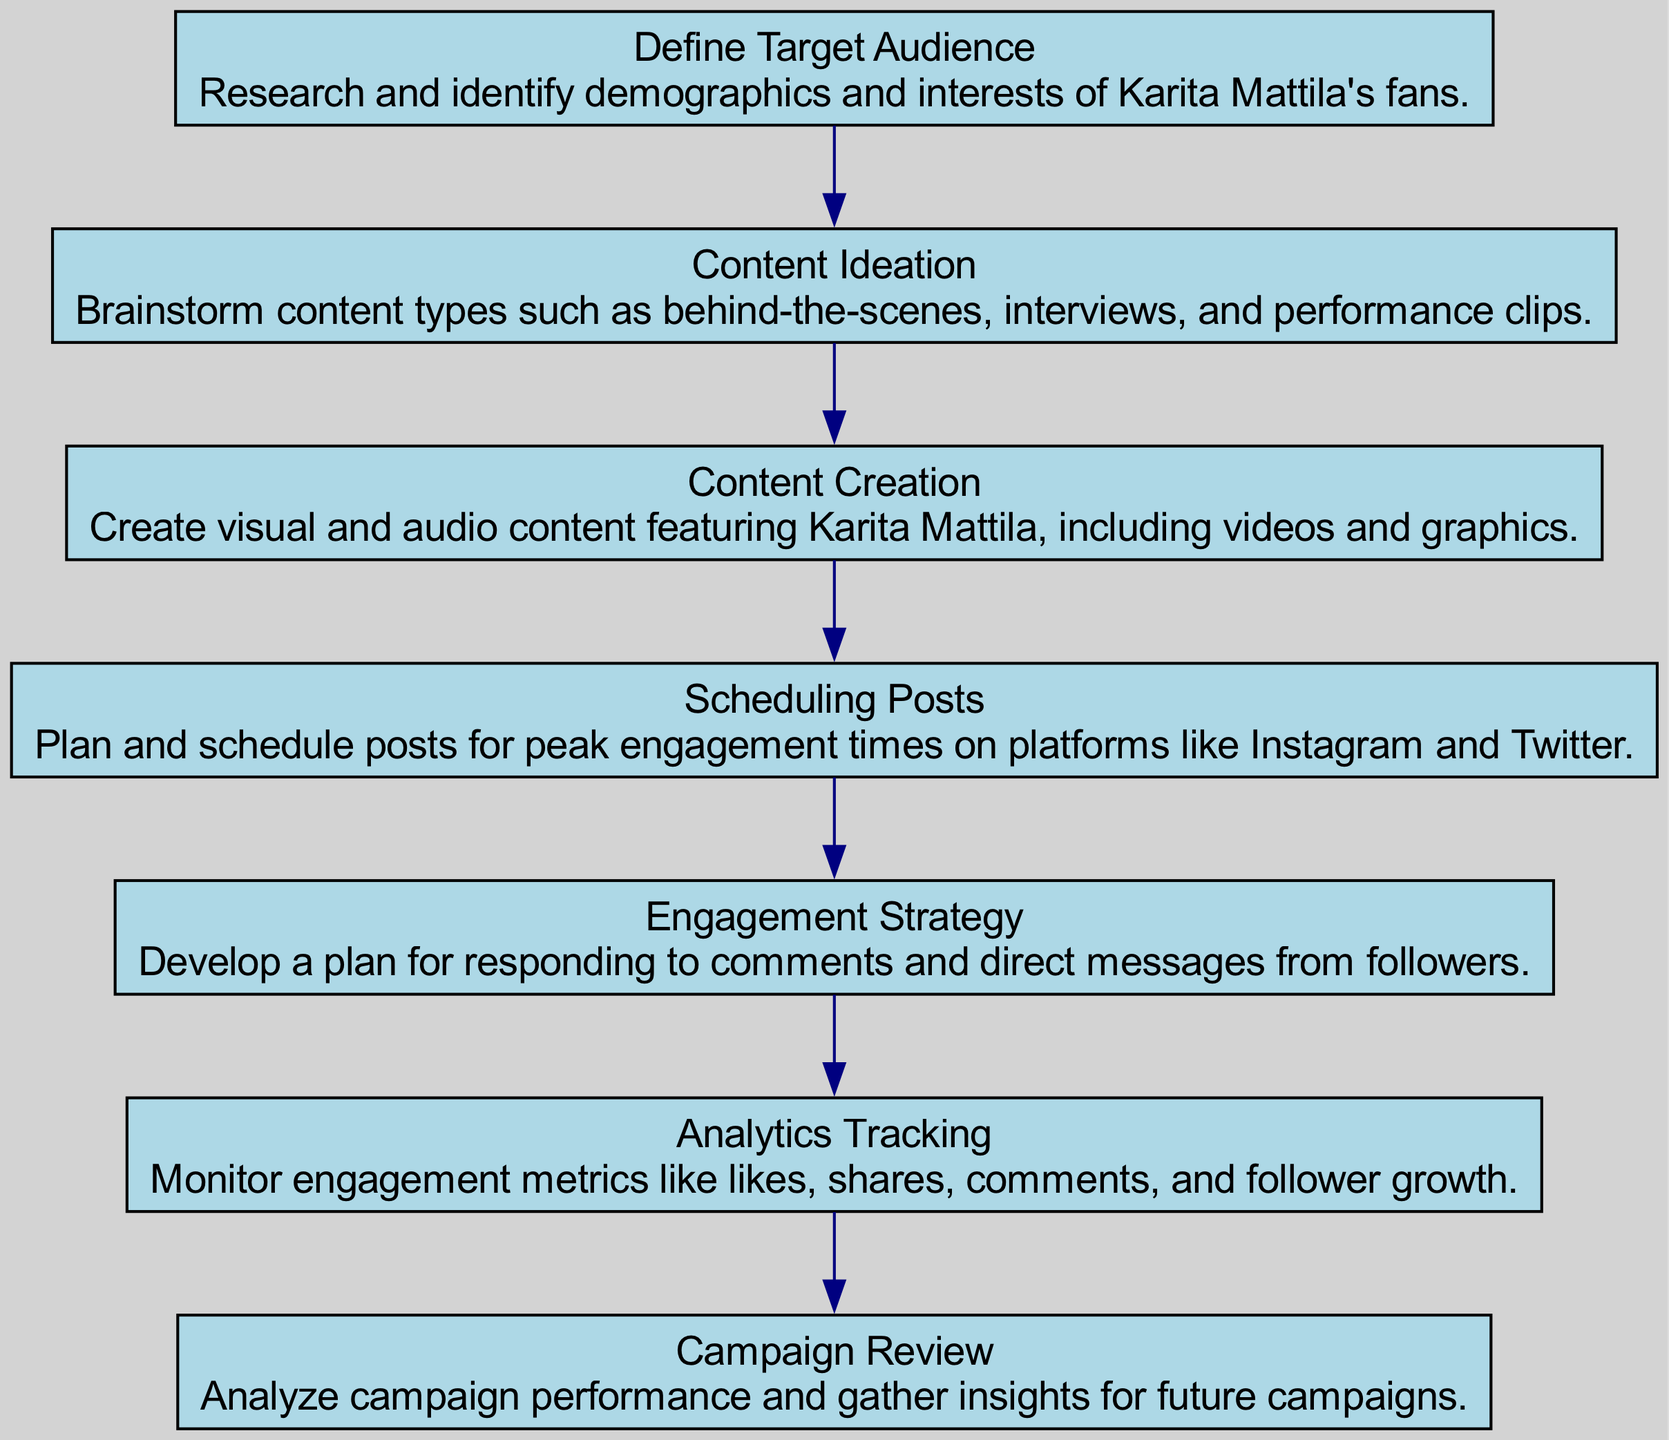What is the first step in the sequence? The first step listed in the diagram is "Define Target Audience" which involves researching and identifying demographics and interests of Karita Mattila's fans.
Answer: Define Target Audience How many nodes are in the diagram? The diagram contains seven nodes, each representing a distinct step in the campaign process.
Answer: 7 What action follows "Content Creation"? The action that directly follows "Content Creation" in the sequence is "Scheduling Posts".
Answer: Scheduling Posts Which step involves plan development for interactions? The step that involves developing a plan for interactions with followers is "Engagement Strategy".
Answer: Engagement Strategy How does "Analytics Tracking" relate to "Campaign Review"? "Analytics Tracking" occurs before "Campaign Review"; it provides the metrics needed for performance analysis in the review stage.
Answer: Before What type of content is created in the "Content Creation" step? The content produced during the "Content Creation" step includes visual and audio content featuring Karita Mattila, such as videos and graphics.
Answer: Visual and audio content What is the last step in the process? The last step of the process outlined in the sequence is "Campaign Review", where performance is analyzed for future insights.
Answer: Campaign Review What is common between "Scheduling Posts" and "Engagement Strategy"? Both "Scheduling Posts" and "Engagement Strategy" are critical for maximizing interaction with the audience, one by timing and the other by responding.
Answer: Maximizing interaction How many actions are identified before "Campaign Review"? There are six actions identified before the "Campaign Review", as it is the last step in the sequence.
Answer: 6 